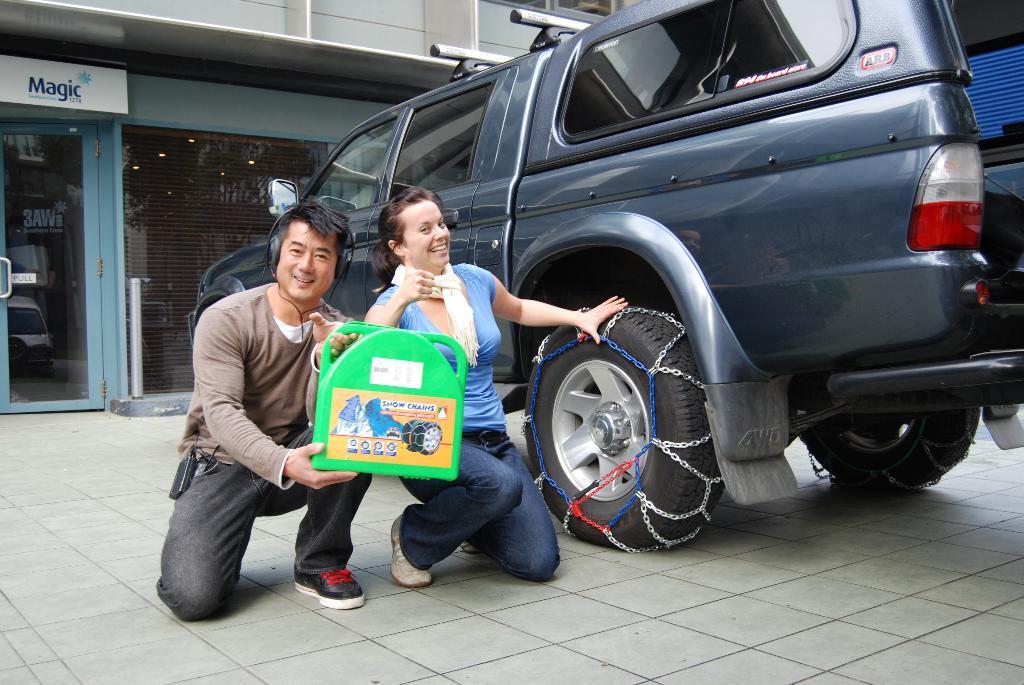Can you describe this image briefly? In this image there are two persons who are kneeling down on the floor by holding the bag. Beside them there is a car. There is a chain which is kept on the Tyre. In the background there is a building. At the bottom there is a glass door. 